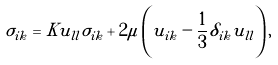<formula> <loc_0><loc_0><loc_500><loc_500>\sigma _ { i k } = K u _ { l l } \sigma _ { i k } + 2 \mu \left ( u _ { i k } - \frac { 1 } { 3 } \delta _ { i k } u _ { l l } \right ) ,</formula> 